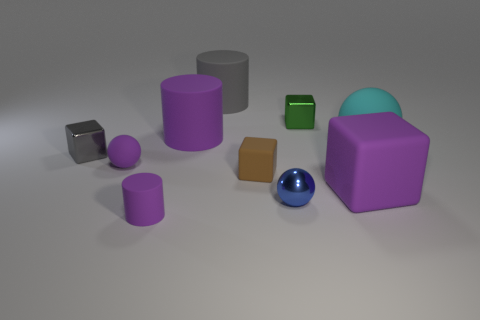There is a matte cube left of the purple matte object right of the tiny metallic cube on the right side of the big gray object; how big is it?
Ensure brevity in your answer.  Small. What is the material of the small cylinder?
Offer a very short reply. Rubber. The matte ball that is the same color as the big matte cube is what size?
Your response must be concise. Small. Do the brown thing and the small purple object in front of the tiny matte cube have the same shape?
Offer a terse response. No. What material is the sphere on the right side of the small shiny block behind the small metal object that is on the left side of the small matte cylinder made of?
Your answer should be very brief. Rubber. How many green metallic blocks are there?
Your response must be concise. 1. How many green objects are either spheres or large cylinders?
Your response must be concise. 0. What number of other objects are the same shape as the big cyan thing?
Offer a very short reply. 2. Does the matte block right of the metallic ball have the same color as the rubber ball that is on the right side of the tiny purple rubber sphere?
Keep it short and to the point. No. What number of small things are either cyan shiny blocks or gray objects?
Offer a very short reply. 1. 